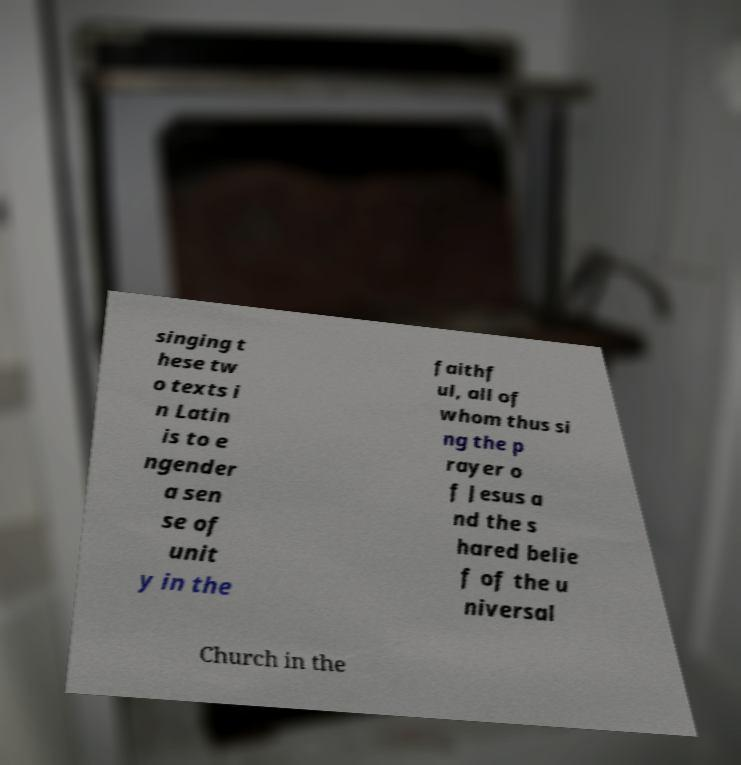Could you extract and type out the text from this image? singing t hese tw o texts i n Latin is to e ngender a sen se of unit y in the faithf ul, all of whom thus si ng the p rayer o f Jesus a nd the s hared belie f of the u niversal Church in the 